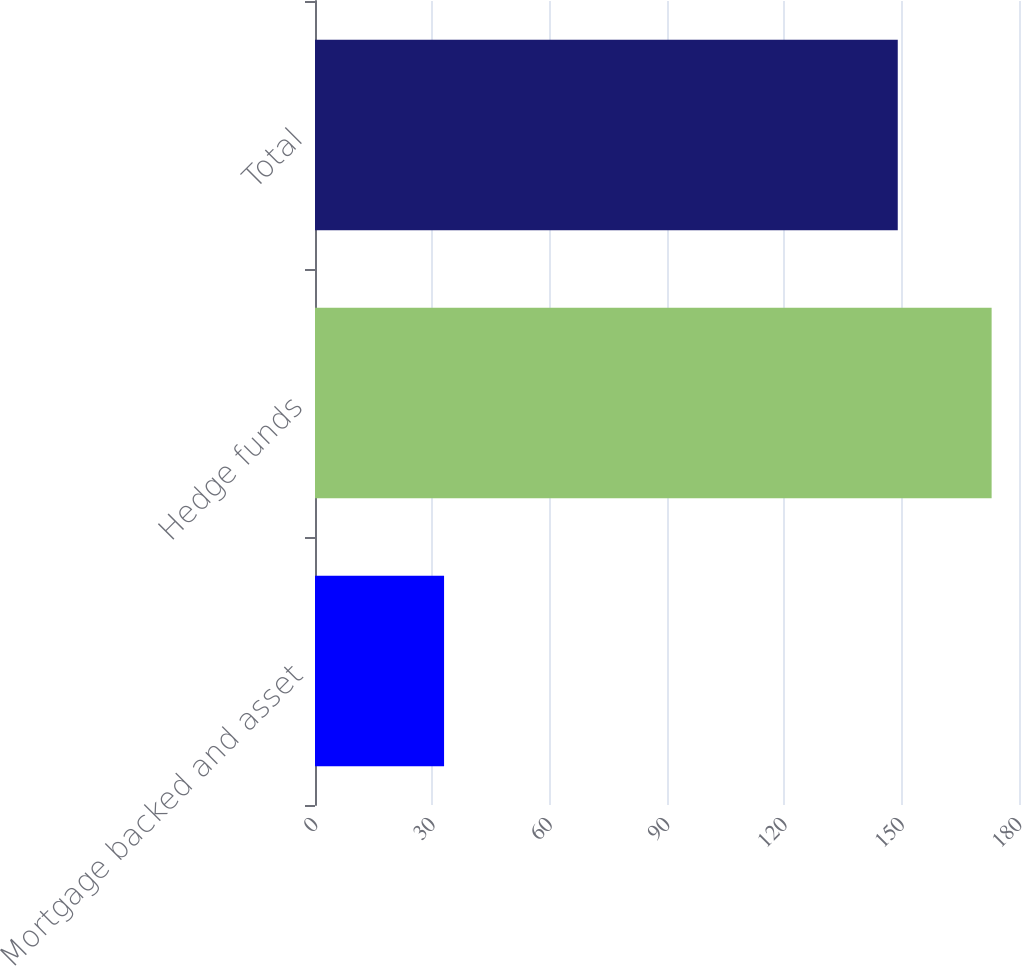Convert chart to OTSL. <chart><loc_0><loc_0><loc_500><loc_500><bar_chart><fcel>Mortgage backed and asset<fcel>Hedge funds<fcel>Total<nl><fcel>33<fcel>173<fcel>149<nl></chart> 